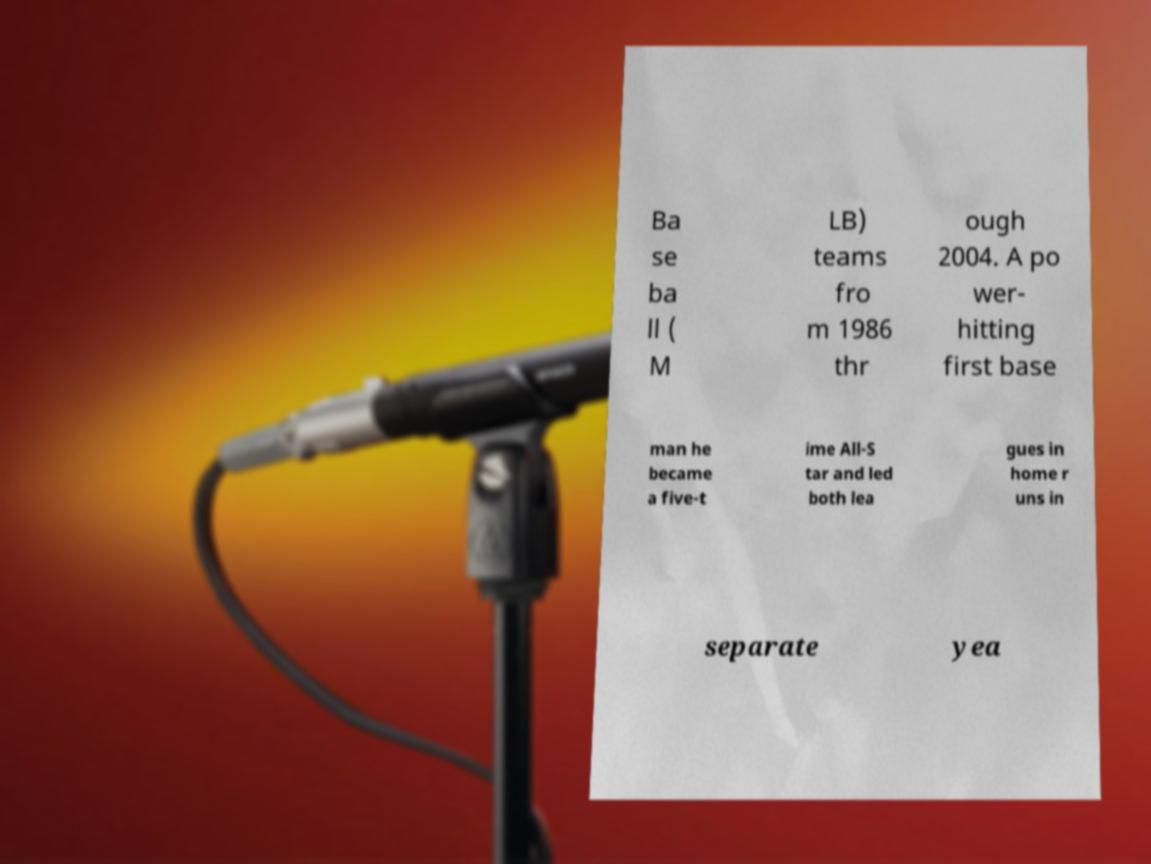For documentation purposes, I need the text within this image transcribed. Could you provide that? Ba se ba ll ( M LB) teams fro m 1986 thr ough 2004. A po wer- hitting first base man he became a five-t ime All-S tar and led both lea gues in home r uns in separate yea 